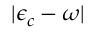<formula> <loc_0><loc_0><loc_500><loc_500>| \epsilon _ { c } - \omega |</formula> 